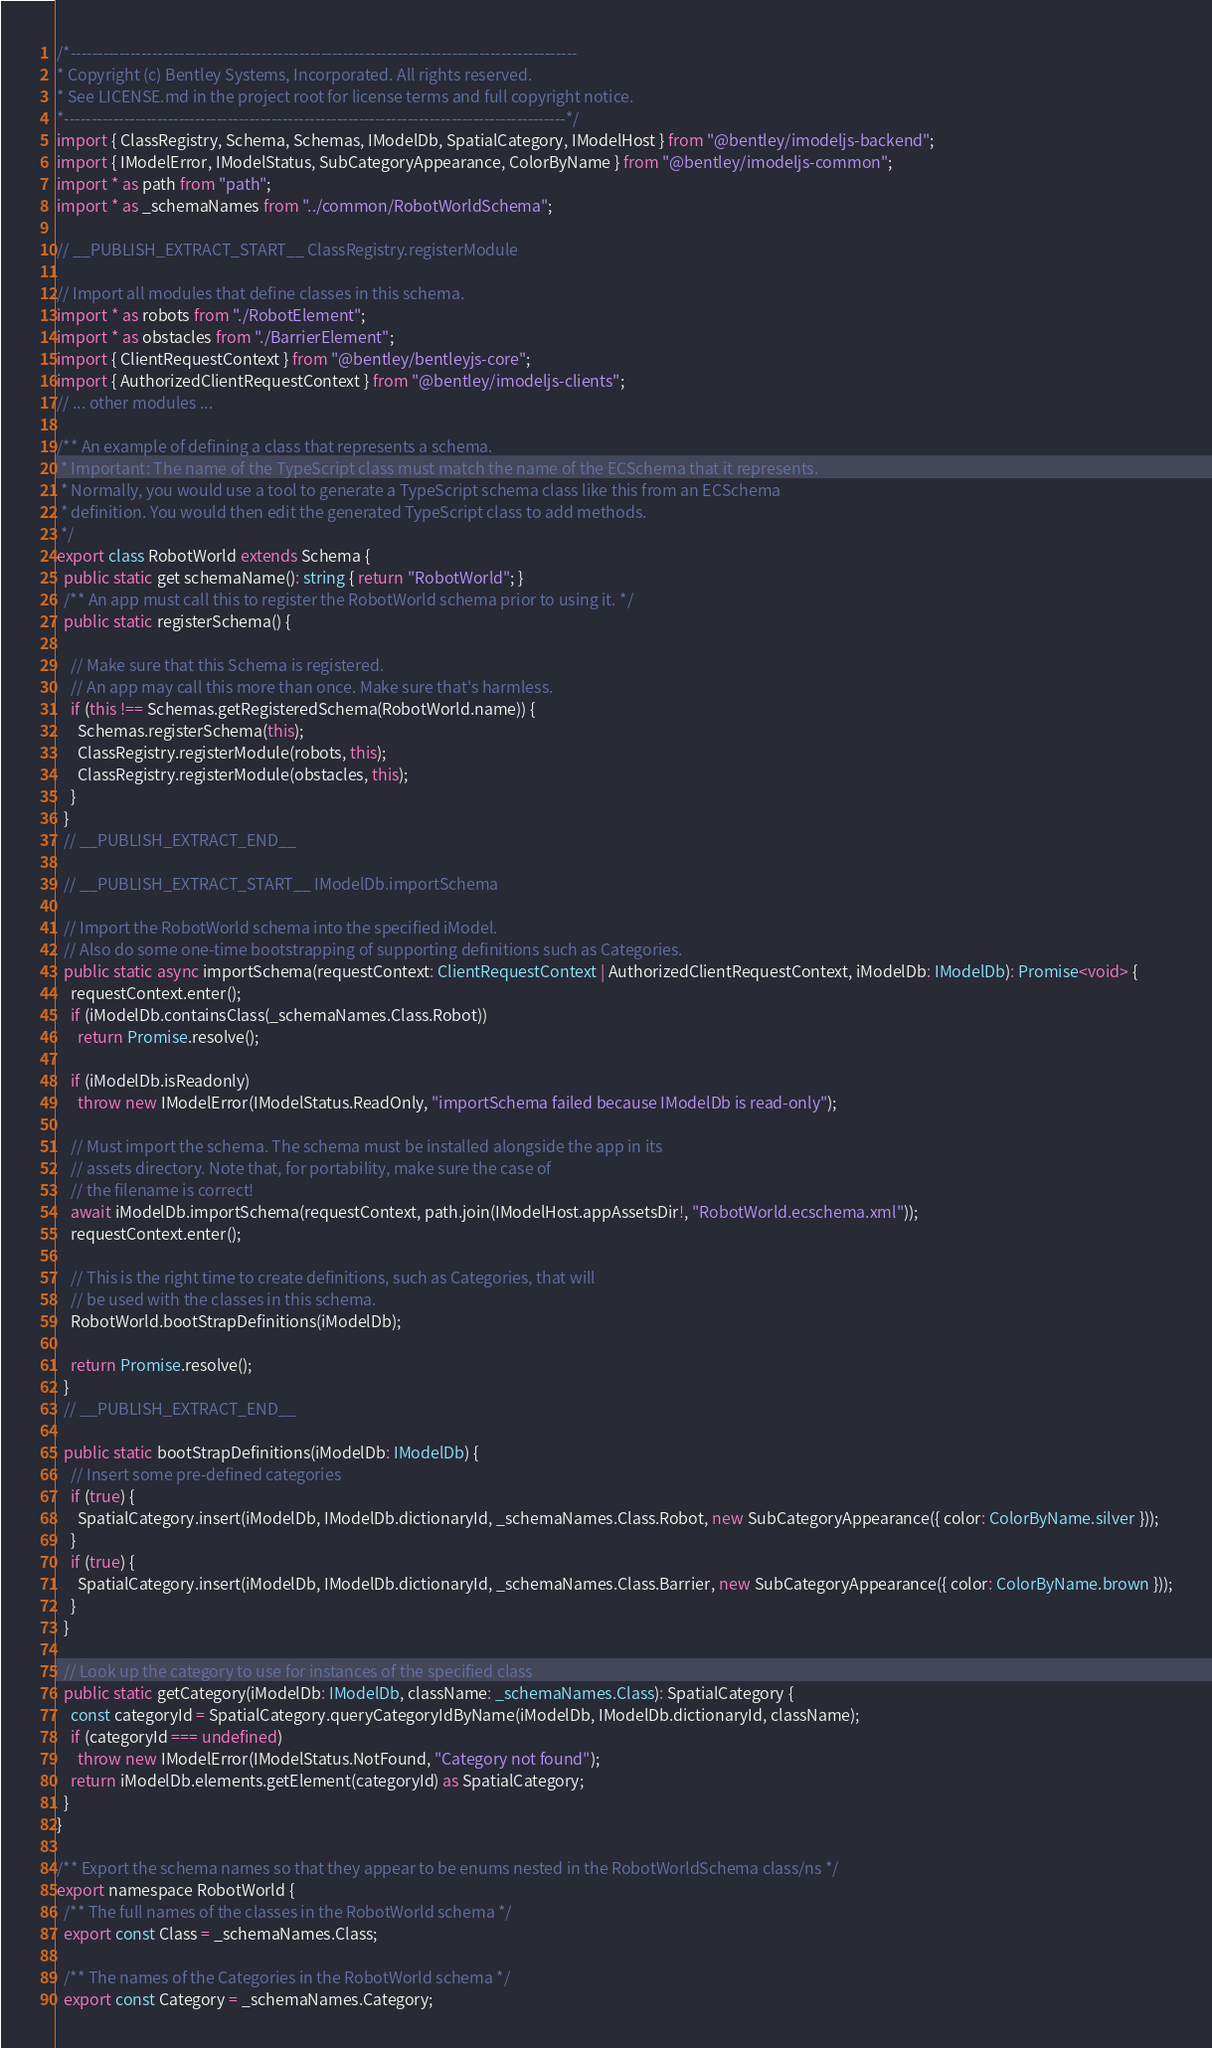<code> <loc_0><loc_0><loc_500><loc_500><_TypeScript_>/*---------------------------------------------------------------------------------------------
* Copyright (c) Bentley Systems, Incorporated. All rights reserved.
* See LICENSE.md in the project root for license terms and full copyright notice.
*--------------------------------------------------------------------------------------------*/
import { ClassRegistry, Schema, Schemas, IModelDb, SpatialCategory, IModelHost } from "@bentley/imodeljs-backend";
import { IModelError, IModelStatus, SubCategoryAppearance, ColorByName } from "@bentley/imodeljs-common";
import * as path from "path";
import * as _schemaNames from "../common/RobotWorldSchema";

// __PUBLISH_EXTRACT_START__ ClassRegistry.registerModule

// Import all modules that define classes in this schema.
import * as robots from "./RobotElement";
import * as obstacles from "./BarrierElement";
import { ClientRequestContext } from "@bentley/bentleyjs-core";
import { AuthorizedClientRequestContext } from "@bentley/imodeljs-clients";
// ... other modules ...

/** An example of defining a class that represents a schema.
 * Important: The name of the TypeScript class must match the name of the ECSchema that it represents.
 * Normally, you would use a tool to generate a TypeScript schema class like this from an ECSchema
 * definition. You would then edit the generated TypeScript class to add methods.
 */
export class RobotWorld extends Schema {
  public static get schemaName(): string { return "RobotWorld"; }
  /** An app must call this to register the RobotWorld schema prior to using it. */
  public static registerSchema() {

    // Make sure that this Schema is registered.
    // An app may call this more than once. Make sure that's harmless.
    if (this !== Schemas.getRegisteredSchema(RobotWorld.name)) {
      Schemas.registerSchema(this);
      ClassRegistry.registerModule(robots, this);
      ClassRegistry.registerModule(obstacles, this);
    }
  }
  // __PUBLISH_EXTRACT_END__

  // __PUBLISH_EXTRACT_START__ IModelDb.importSchema

  // Import the RobotWorld schema into the specified iModel.
  // Also do some one-time bootstrapping of supporting definitions such as Categories.
  public static async importSchema(requestContext: ClientRequestContext | AuthorizedClientRequestContext, iModelDb: IModelDb): Promise<void> {
    requestContext.enter();
    if (iModelDb.containsClass(_schemaNames.Class.Robot))
      return Promise.resolve();

    if (iModelDb.isReadonly)
      throw new IModelError(IModelStatus.ReadOnly, "importSchema failed because IModelDb is read-only");

    // Must import the schema. The schema must be installed alongside the app in its
    // assets directory. Note that, for portability, make sure the case of
    // the filename is correct!
    await iModelDb.importSchema(requestContext, path.join(IModelHost.appAssetsDir!, "RobotWorld.ecschema.xml"));
    requestContext.enter();

    // This is the right time to create definitions, such as Categories, that will
    // be used with the classes in this schema.
    RobotWorld.bootStrapDefinitions(iModelDb);

    return Promise.resolve();
  }
  // __PUBLISH_EXTRACT_END__

  public static bootStrapDefinitions(iModelDb: IModelDb) {
    // Insert some pre-defined categories
    if (true) {
      SpatialCategory.insert(iModelDb, IModelDb.dictionaryId, _schemaNames.Class.Robot, new SubCategoryAppearance({ color: ColorByName.silver }));
    }
    if (true) {
      SpatialCategory.insert(iModelDb, IModelDb.dictionaryId, _schemaNames.Class.Barrier, new SubCategoryAppearance({ color: ColorByName.brown }));
    }
  }

  // Look up the category to use for instances of the specified class
  public static getCategory(iModelDb: IModelDb, className: _schemaNames.Class): SpatialCategory {
    const categoryId = SpatialCategory.queryCategoryIdByName(iModelDb, IModelDb.dictionaryId, className);
    if (categoryId === undefined)
      throw new IModelError(IModelStatus.NotFound, "Category not found");
    return iModelDb.elements.getElement(categoryId) as SpatialCategory;
  }
}

/** Export the schema names so that they appear to be enums nested in the RobotWorldSchema class/ns */
export namespace RobotWorld {
  /** The full names of the classes in the RobotWorld schema */
  export const Class = _schemaNames.Class;

  /** The names of the Categories in the RobotWorld schema */
  export const Category = _schemaNames.Category;
</code> 